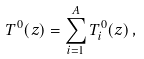<formula> <loc_0><loc_0><loc_500><loc_500>T ^ { 0 } ( z ) = \sum ^ { A } _ { i = 1 } T ^ { 0 } _ { i } ( z ) \, ,</formula> 